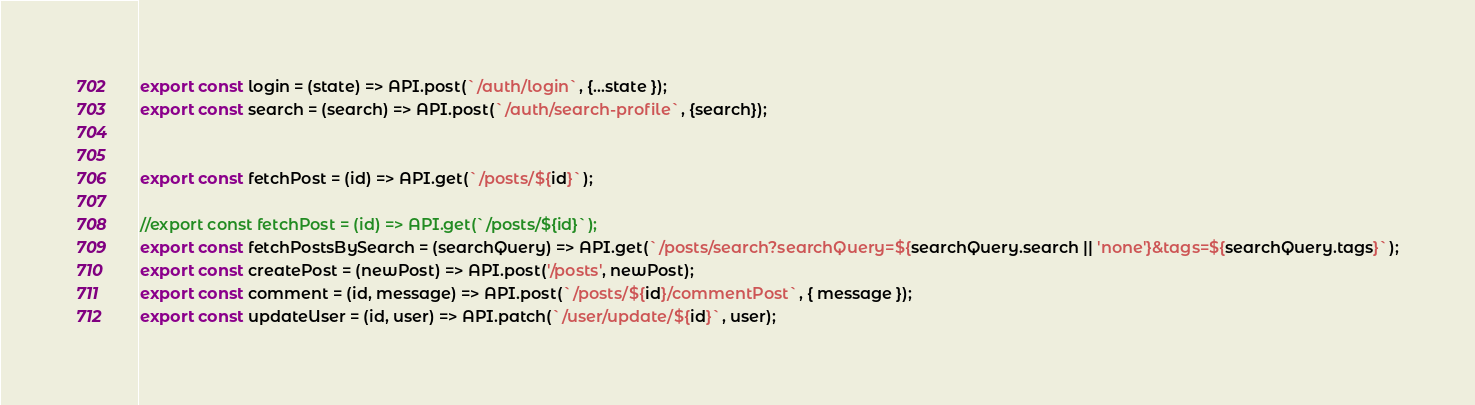<code> <loc_0><loc_0><loc_500><loc_500><_JavaScript_>export const login = (state) => API.post(`/auth/login`, {...state });
export const search = (search) => API.post(`/auth/search-profile`, {search});


export const fetchPost = (id) => API.get(`/posts/${id}`);

//export const fetchPost = (id) => API.get(`/posts/${id}`);
export const fetchPostsBySearch = (searchQuery) => API.get(`/posts/search?searchQuery=${searchQuery.search || 'none'}&tags=${searchQuery.tags}`);
export const createPost = (newPost) => API.post('/posts', newPost);
export const comment = (id, message) => API.post(`/posts/${id}/commentPost`, { message });
export const updateUser = (id, user) => API.patch(`/user/update/${id}`, user);
</code> 